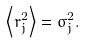<formula> <loc_0><loc_0><loc_500><loc_500>\left \langle r _ { j } ^ { 2 } \right \rangle = \sigma _ { j } ^ { 2 } .</formula> 